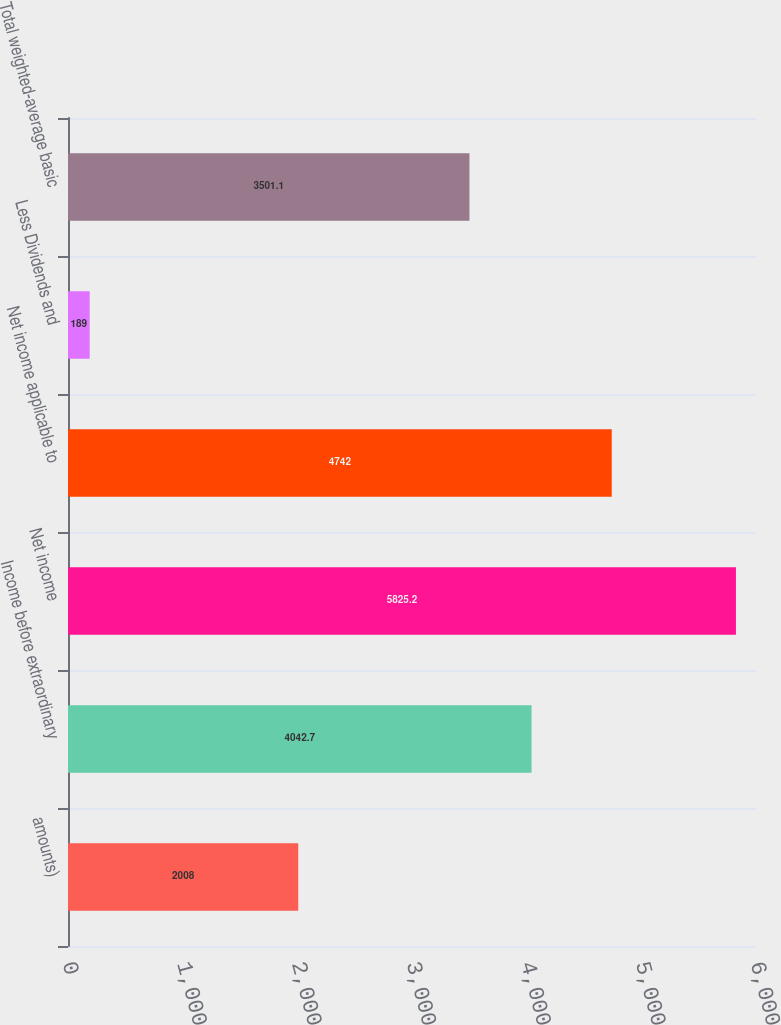Convert chart. <chart><loc_0><loc_0><loc_500><loc_500><bar_chart><fcel>amounts)<fcel>Income before extraordinary<fcel>Net income<fcel>Net income applicable to<fcel>Less Dividends and<fcel>Total weighted-average basic<nl><fcel>2008<fcel>4042.7<fcel>5825.2<fcel>4742<fcel>189<fcel>3501.1<nl></chart> 